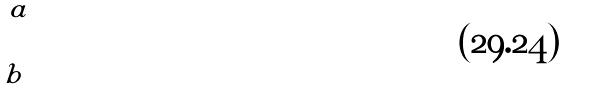<formula> <loc_0><loc_0><loc_500><loc_500>\int _ { b } ^ { a }</formula> 